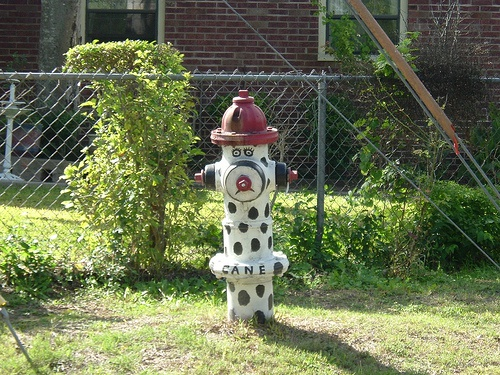Describe the objects in this image and their specific colors. I can see a fire hydrant in black, darkgray, white, and gray tones in this image. 